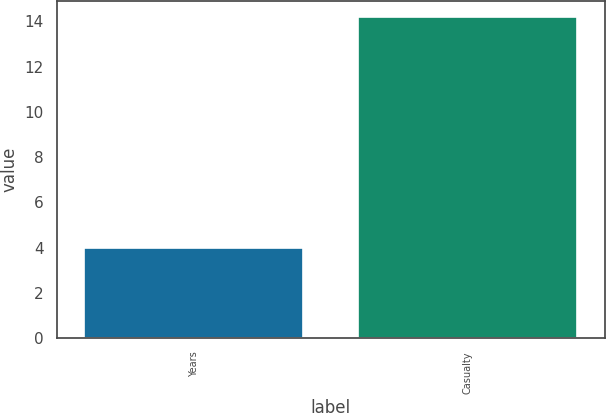Convert chart. <chart><loc_0><loc_0><loc_500><loc_500><bar_chart><fcel>Years<fcel>Casualty<nl><fcel>4<fcel>14.2<nl></chart> 